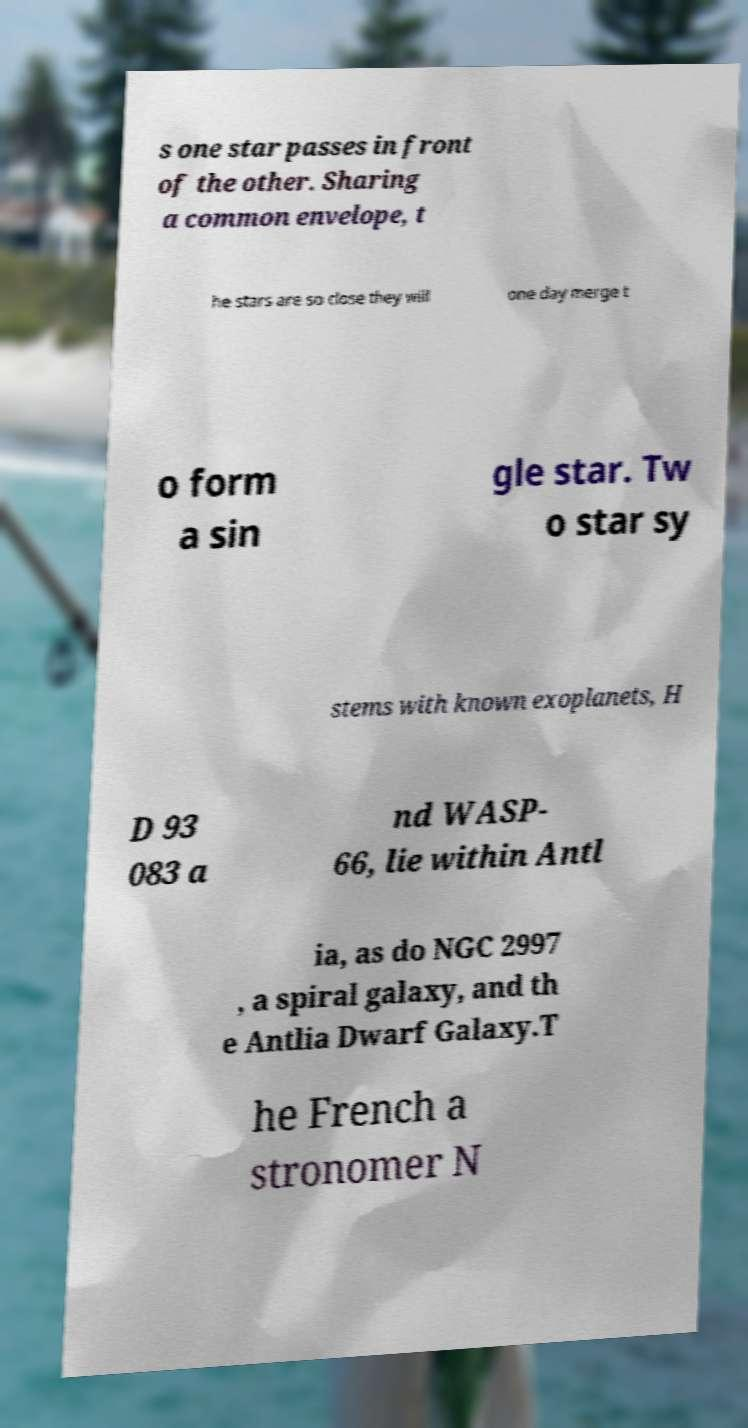Could you assist in decoding the text presented in this image and type it out clearly? s one star passes in front of the other. Sharing a common envelope, t he stars are so close they will one day merge t o form a sin gle star. Tw o star sy stems with known exoplanets, H D 93 083 a nd WASP- 66, lie within Antl ia, as do NGC 2997 , a spiral galaxy, and th e Antlia Dwarf Galaxy.T he French a stronomer N 